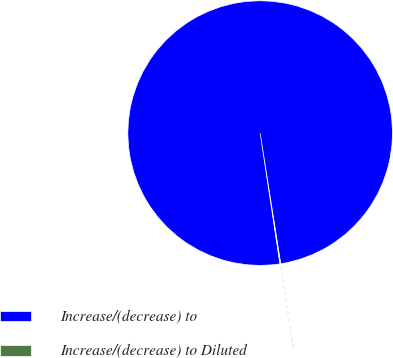<chart> <loc_0><loc_0><loc_500><loc_500><pie_chart><fcel>Increase/(decrease) to<fcel>Increase/(decrease) to Diluted<nl><fcel>99.9%<fcel>0.1%<nl></chart> 